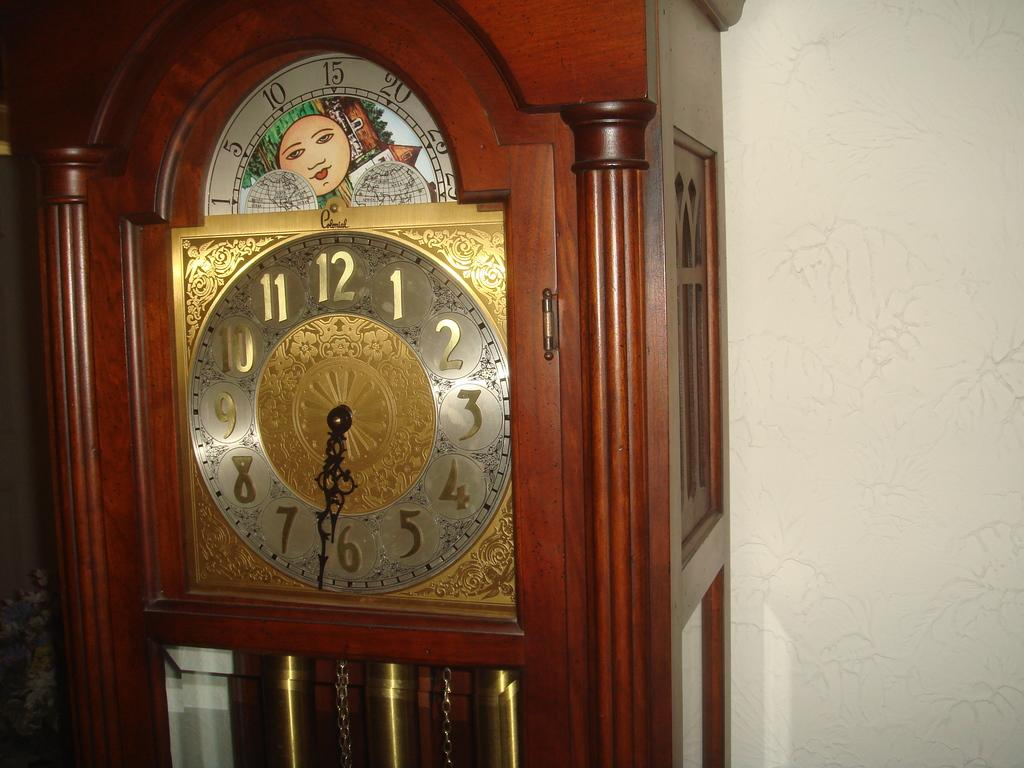Provide a one-sentence caption for the provided image. A large, wooden grandfather clock with the time displayed of 6:32. 